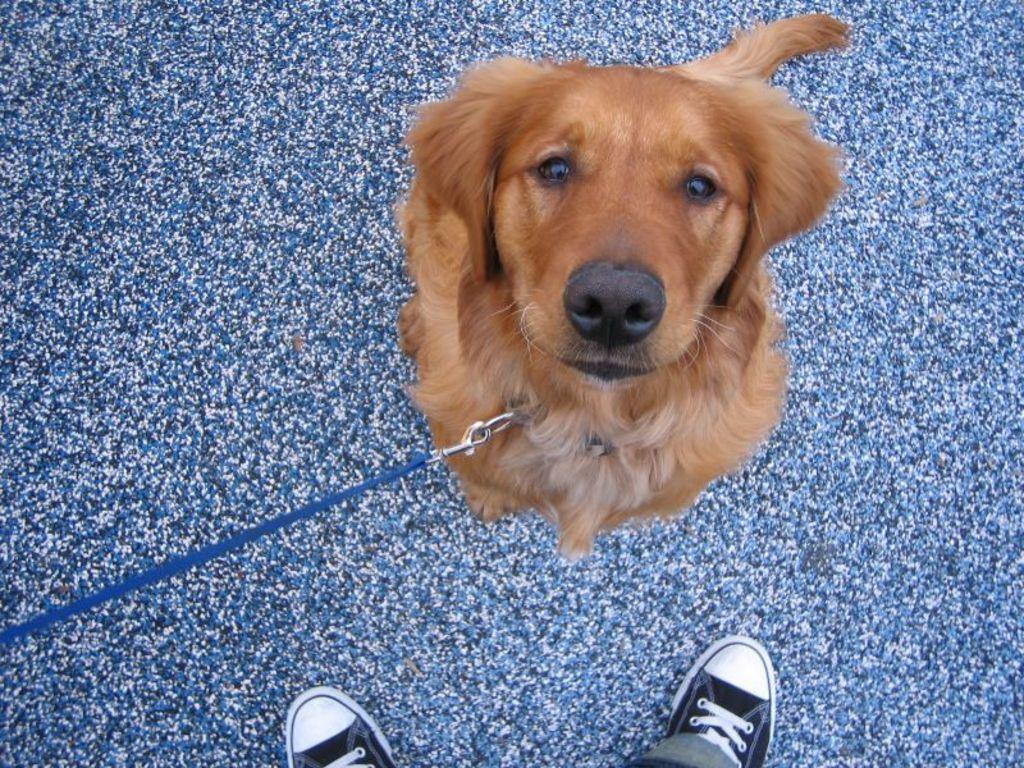Describe this image in one or two sentences. In this image there is a dog and we can see the shoes of a person. At the bottom of the image there is a mat. 